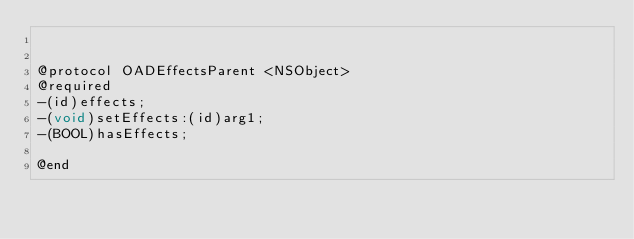Convert code to text. <code><loc_0><loc_0><loc_500><loc_500><_C_>

@protocol OADEffectsParent <NSObject>
@required
-(id)effects;
-(void)setEffects:(id)arg1;
-(BOOL)hasEffects;

@end

</code> 